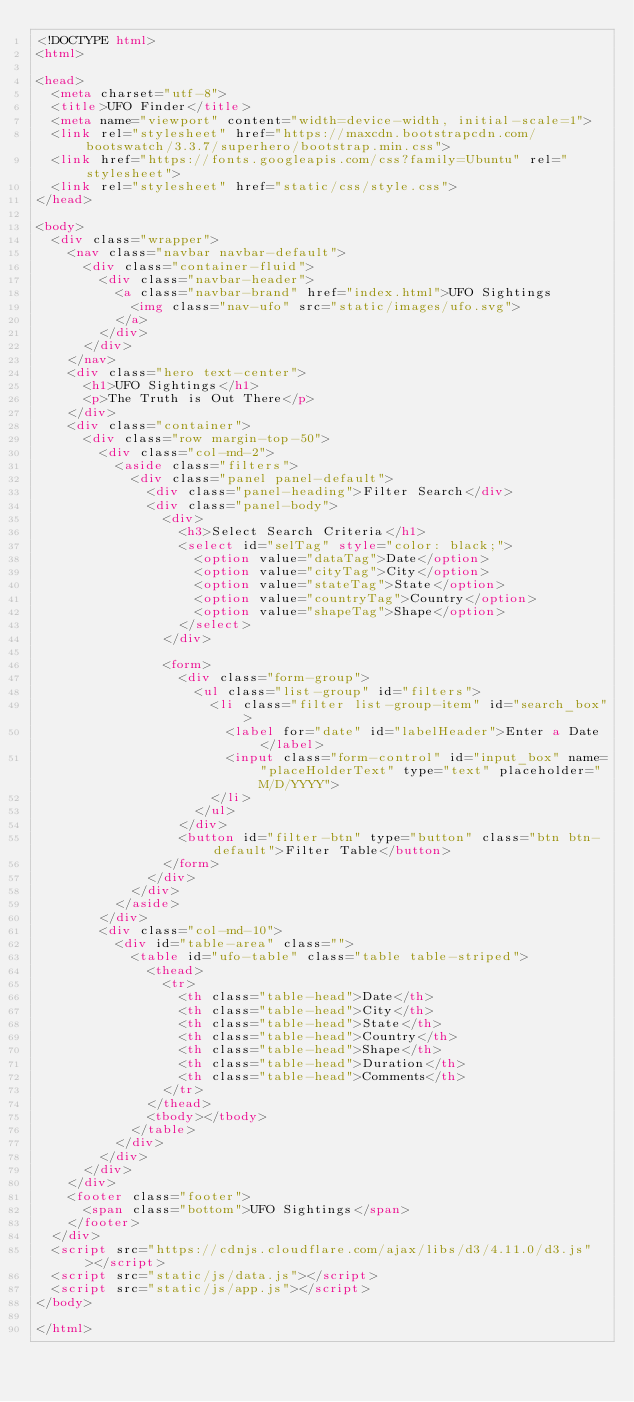<code> <loc_0><loc_0><loc_500><loc_500><_HTML_><!DOCTYPE html>
<html>

<head>
  <meta charset="utf-8">
  <title>UFO Finder</title>
  <meta name="viewport" content="width=device-width, initial-scale=1">
  <link rel="stylesheet" href="https://maxcdn.bootstrapcdn.com/bootswatch/3.3.7/superhero/bootstrap.min.css">
  <link href="https://fonts.googleapis.com/css?family=Ubuntu" rel="stylesheet">
  <link rel="stylesheet" href="static/css/style.css">
</head>

<body>
  <div class="wrapper">
    <nav class="navbar navbar-default">
      <div class="container-fluid">
        <div class="navbar-header">
          <a class="navbar-brand" href="index.html">UFO Sightings
            <img class="nav-ufo" src="static/images/ufo.svg">
          </a>
        </div>
      </div>
    </nav>
    <div class="hero text-center">
      <h1>UFO Sightings</h1>
      <p>The Truth is Out There</p>
    </div>
    <div class="container">
      <div class="row margin-top-50">
        <div class="col-md-2">
          <aside class="filters">
            <div class="panel panel-default">
              <div class="panel-heading">Filter Search</div>
              <div class="panel-body">
                <div>
                  <h3>Select Search Criteria</h1>
                  <select id="selTag" style="color: black;">
                    <option value="dataTag">Date</option>
                    <option value="cityTag">City</option>
                    <option value="stateTag">State</option>
                    <option value="countryTag">Country</option>
                    <option value="shapeTag">Shape</option>
                  </select>
                </div>

                <form>
                  <div class="form-group">
                    <ul class="list-group" id="filters">
                      <li class="filter list-group-item" id="search_box">
                        <label for="date" id="labelHeader">Enter a Date</label>
                        <input class="form-control" id="input_box" name="placeHolderText" type="text" placeholder="M/D/YYYY">
                      </li>
                    </ul>
                  </div>
                  <button id="filter-btn" type="button" class="btn btn-default">Filter Table</button>
                </form>
              </div>
            </div>
          </aside>
        </div>
        <div class="col-md-10">
          <div id="table-area" class="">
            <table id="ufo-table" class="table table-striped">
              <thead>
                <tr>
                  <th class="table-head">Date</th>
                  <th class="table-head">City</th>
                  <th class="table-head">State</th>
                  <th class="table-head">Country</th>
                  <th class="table-head">Shape</th>
                  <th class="table-head">Duration</th>
                  <th class="table-head">Comments</th>
                </tr>
              </thead>
              <tbody></tbody>
            </table>
          </div>
        </div>
      </div>
    </div>
    <footer class="footer">
      <span class="bottom">UFO Sightings</span>
    </footer>
  </div>
  <script src="https://cdnjs.cloudflare.com/ajax/libs/d3/4.11.0/d3.js"></script>
  <script src="static/js/data.js"></script>
  <script src="static/js/app.js"></script>
</body>

</html>
</code> 